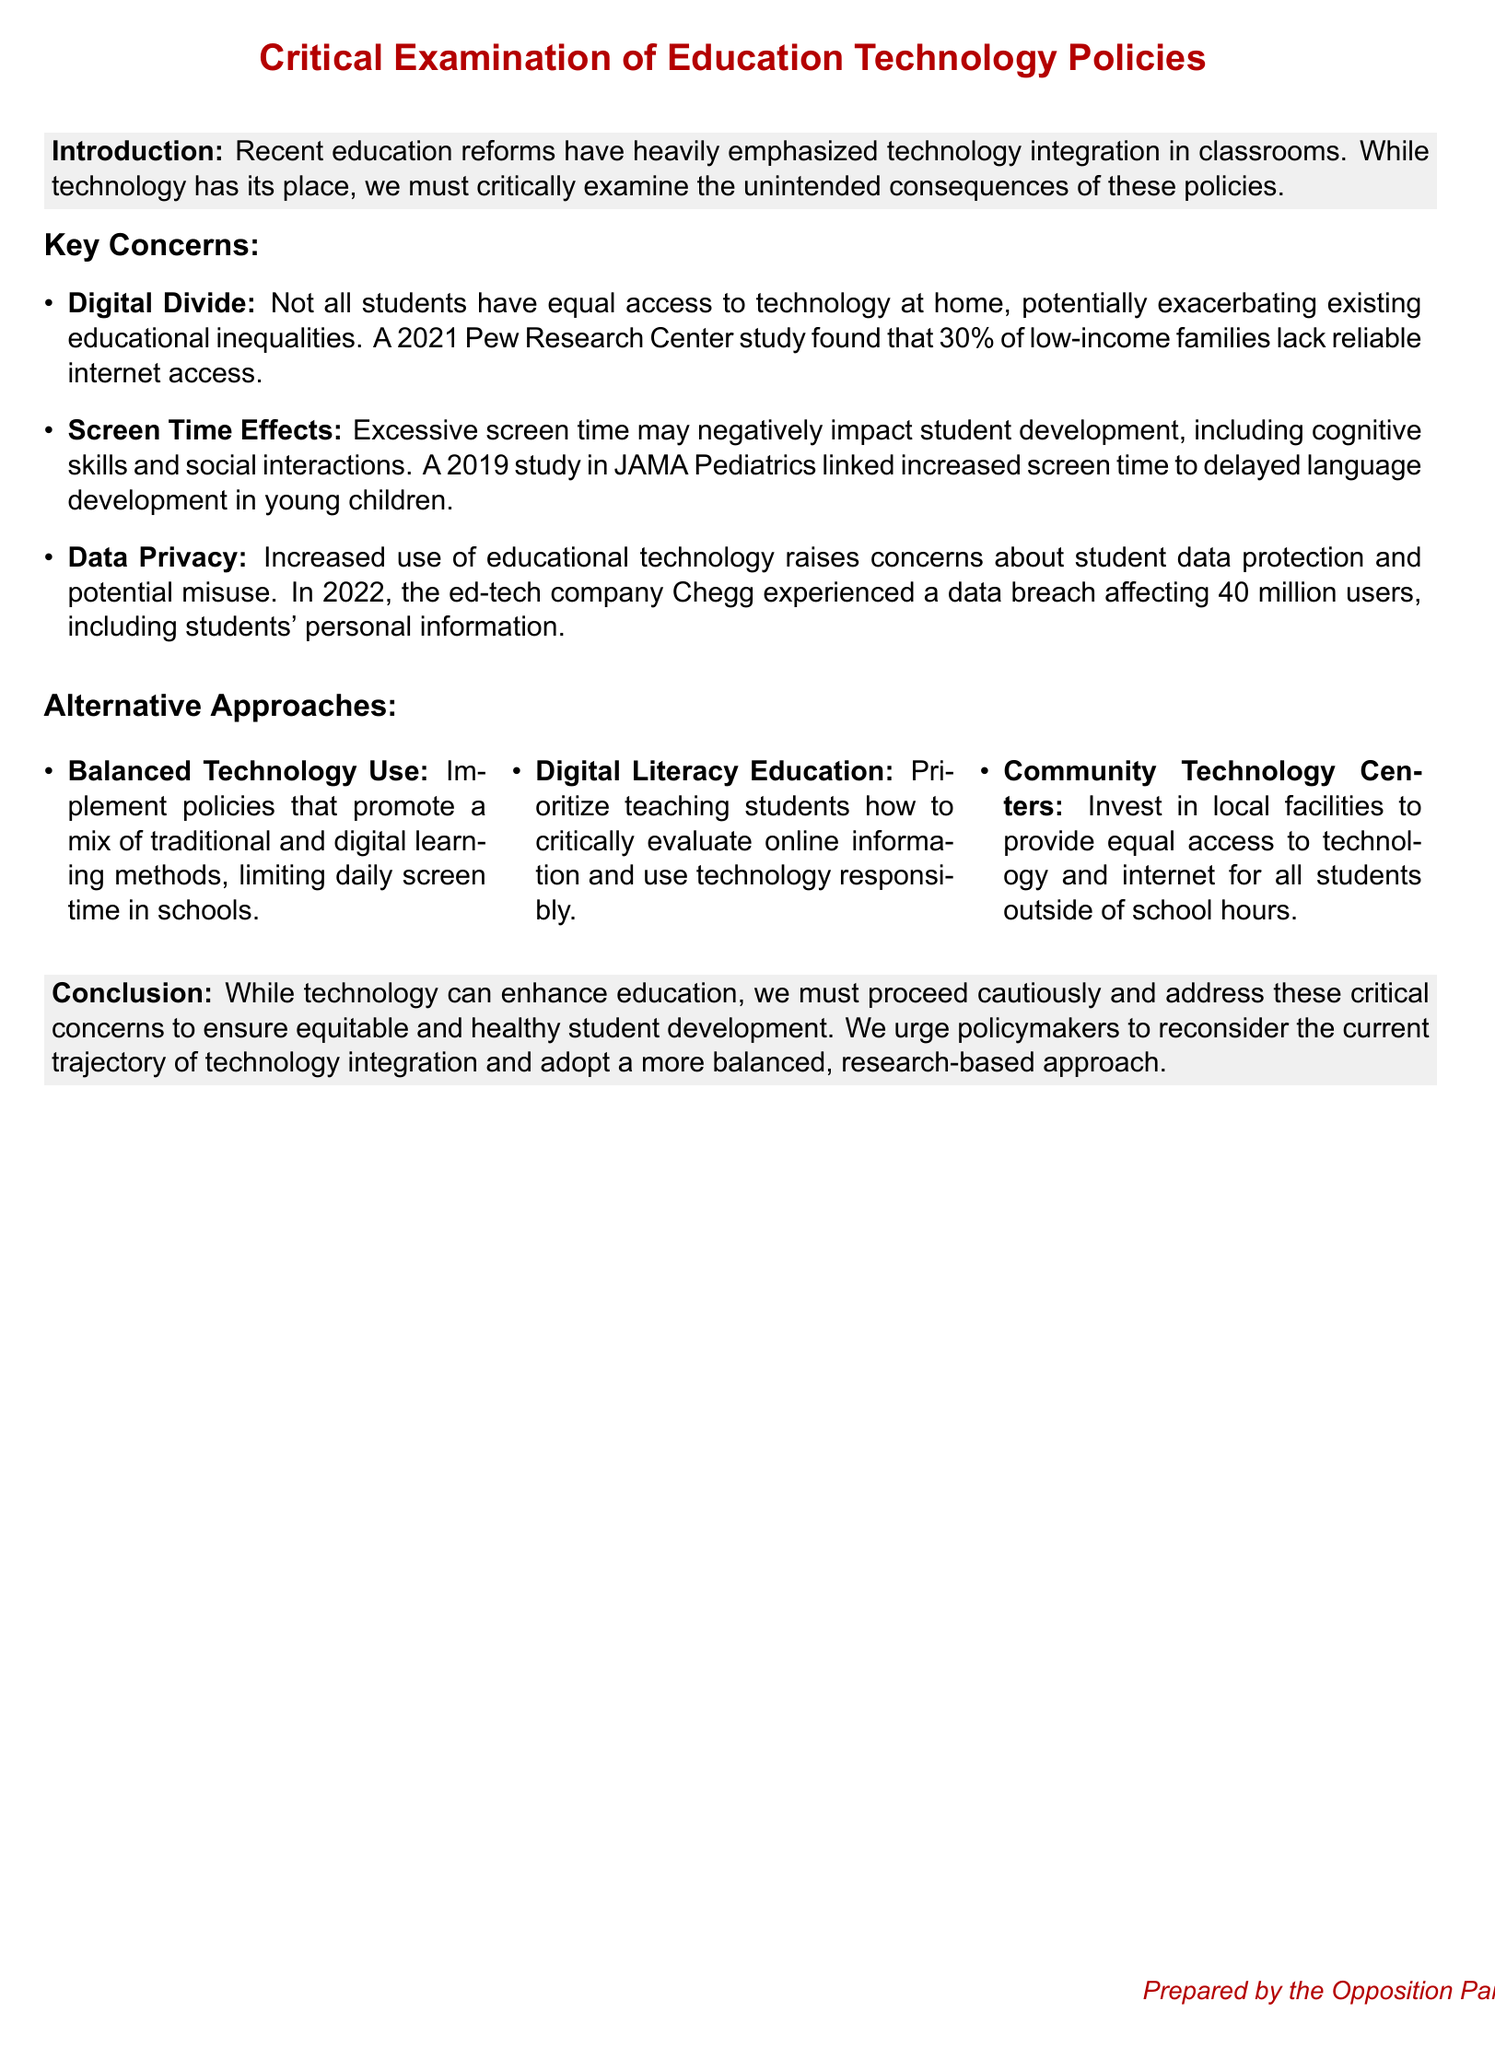What is the percentage of low-income families without reliable internet access? The document cites a 2021 Pew Research Center study that found 30% of low-income families lack reliable internet access.
Answer: 30% What organization conducted the study linking excessive screen time to delayed language development? The 2019 study mentioned is from JAMA Pediatrics.
Answer: JAMA Pediatrics What year did the data breach affecting Chegg occur? The document states that the data breach affecting Chegg happened in 2022.
Answer: 2022 What type of policy is suggested to limit daily screen time in schools? The document proposes implementing policies that promote a mix of traditional and digital learning methods.
Answer: Balanced Technology Use What is one alternative approach to address digital equity mentioned in the document? The document suggests investing in Community Technology Centers to provide equal access to technology.
Answer: Community Technology Centers How many users were affected by Chegg's data breach? According to the document, the data breach affected 40 million users, including students.
Answer: 40 million What is a key concern related to increased use of educational technology? The document identifies data privacy as a key concern related to increased use of educational technology.
Answer: Data Privacy What type of education should be prioritized according to the alternative approaches? The document emphasizes the need for Digital Literacy Education to teach responsible technology use.
Answer: Digital Literacy Education 